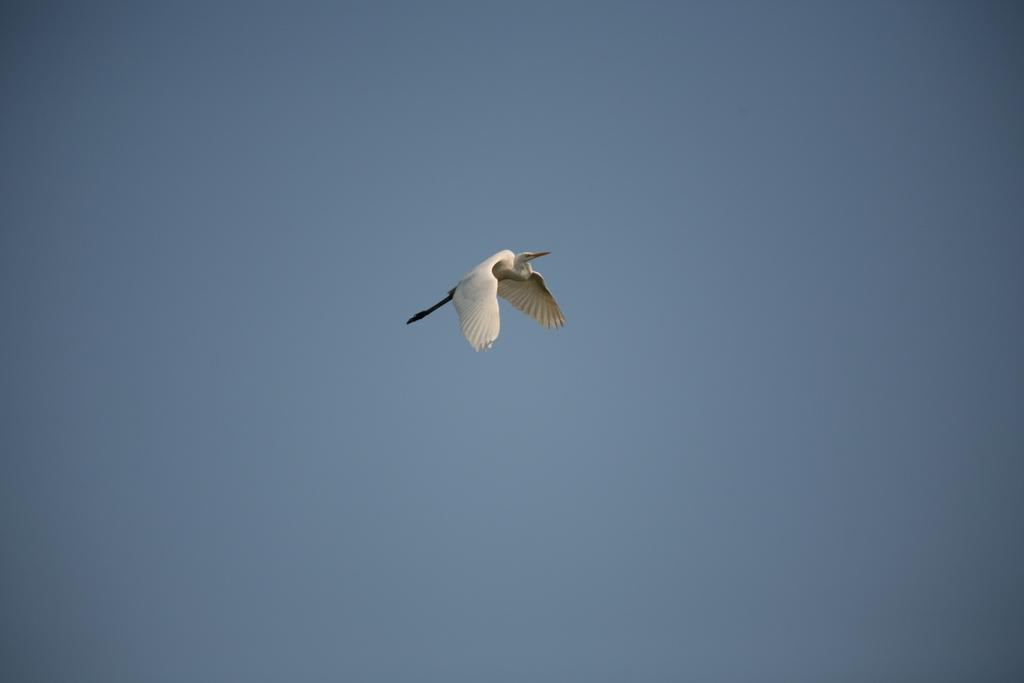What type of animal can be seen in the image? There is a bird in the image. What is the bird doing in the image? The bird is flying in the sky. Where is the throne located in the image? There is no throne present in the image. What holiday is being celebrated in the image? There is no indication of a holiday being celebrated in the image. 